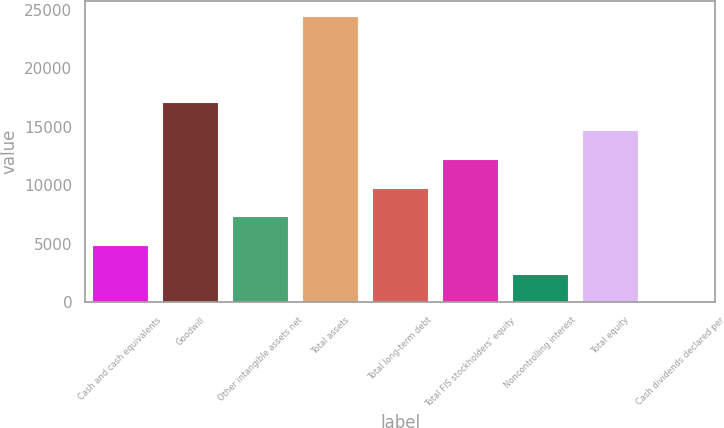Convert chart. <chart><loc_0><loc_0><loc_500><loc_500><bar_chart><fcel>Cash and cash equivalents<fcel>Goodwill<fcel>Other intangible assets net<fcel>Total assets<fcel>Total long-term debt<fcel>Total FIS stockholders' equity<fcel>Noncontrolling interest<fcel>Total equity<fcel>Cash dividends declared per<nl><fcel>4904.32<fcel>17162.2<fcel>7355.9<fcel>24517<fcel>9807.48<fcel>12259.1<fcel>2452.74<fcel>14710.6<fcel>1.16<nl></chart> 